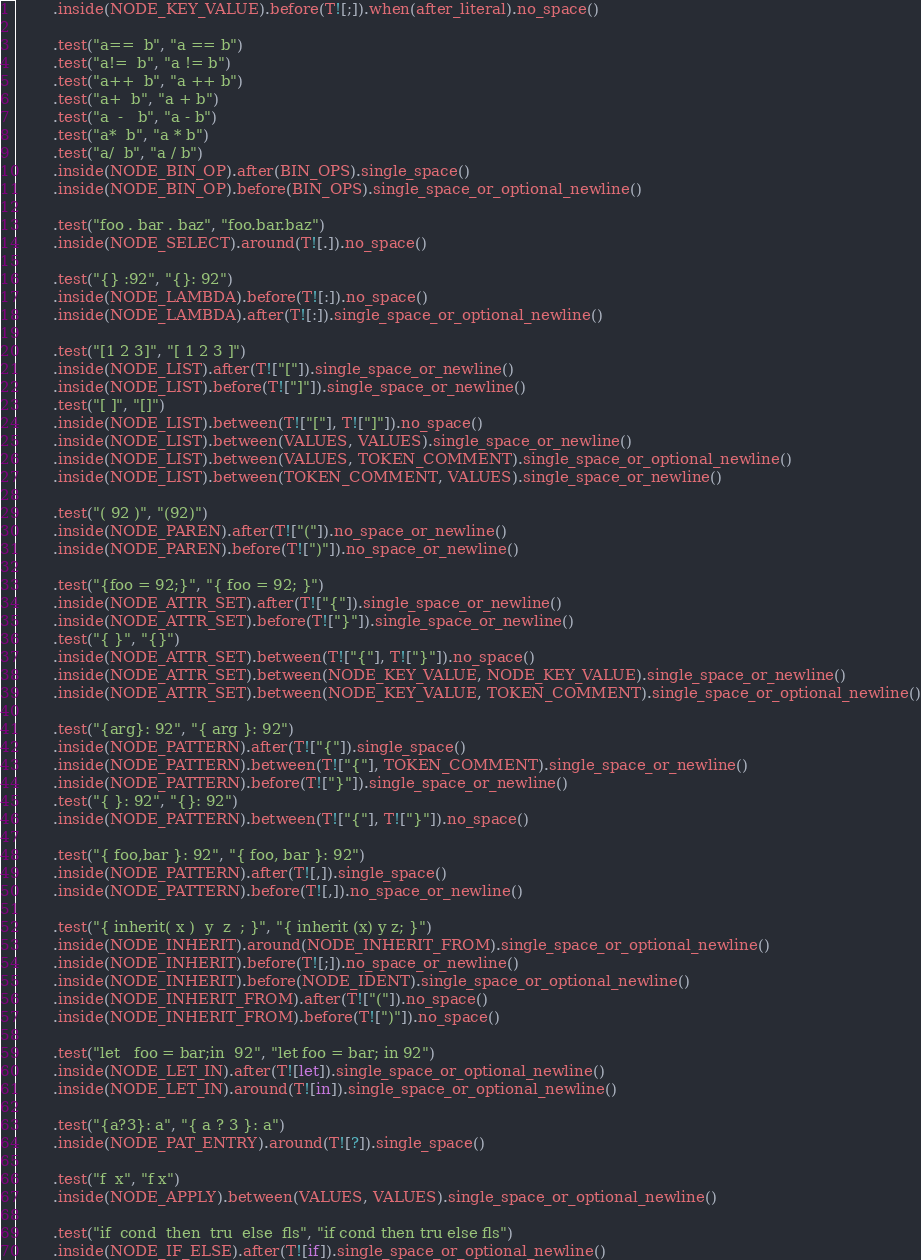Convert code to text. <code><loc_0><loc_0><loc_500><loc_500><_Rust_>        .inside(NODE_KEY_VALUE).before(T![;]).when(after_literal).no_space()

        .test("a==  b", "a == b")
        .test("a!=  b", "a != b")
        .test("a++  b", "a ++ b")
        .test("a+  b", "a + b")
        .test("a  -   b", "a - b")
        .test("a*  b", "a * b")
        .test("a/  b", "a / b")
        .inside(NODE_BIN_OP).after(BIN_OPS).single_space()
        .inside(NODE_BIN_OP).before(BIN_OPS).single_space_or_optional_newline()

        .test("foo . bar . baz", "foo.bar.baz")
        .inside(NODE_SELECT).around(T![.]).no_space()

        .test("{} :92", "{}: 92")
        .inside(NODE_LAMBDA).before(T![:]).no_space()
        .inside(NODE_LAMBDA).after(T![:]).single_space_or_optional_newline()

        .test("[1 2 3]", "[ 1 2 3 ]")
        .inside(NODE_LIST).after(T!["["]).single_space_or_newline()
        .inside(NODE_LIST).before(T!["]"]).single_space_or_newline()
        .test("[ ]", "[]")
        .inside(NODE_LIST).between(T!["["], T!["]"]).no_space()
        .inside(NODE_LIST).between(VALUES, VALUES).single_space_or_newline()
        .inside(NODE_LIST).between(VALUES, TOKEN_COMMENT).single_space_or_optional_newline()
        .inside(NODE_LIST).between(TOKEN_COMMENT, VALUES).single_space_or_newline()

        .test("( 92 )", "(92)")
        .inside(NODE_PAREN).after(T!["("]).no_space_or_newline()
        .inside(NODE_PAREN).before(T![")"]).no_space_or_newline()

        .test("{foo = 92;}", "{ foo = 92; }")
        .inside(NODE_ATTR_SET).after(T!["{"]).single_space_or_newline()
        .inside(NODE_ATTR_SET).before(T!["}"]).single_space_or_newline()
        .test("{ }", "{}")
        .inside(NODE_ATTR_SET).between(T!["{"], T!["}"]).no_space()
        .inside(NODE_ATTR_SET).between(NODE_KEY_VALUE, NODE_KEY_VALUE).single_space_or_newline()
        .inside(NODE_ATTR_SET).between(NODE_KEY_VALUE, TOKEN_COMMENT).single_space_or_optional_newline()

        .test("{arg}: 92", "{ arg }: 92")
        .inside(NODE_PATTERN).after(T!["{"]).single_space()
        .inside(NODE_PATTERN).between(T!["{"], TOKEN_COMMENT).single_space_or_newline()
        .inside(NODE_PATTERN).before(T!["}"]).single_space_or_newline()
        .test("{ }: 92", "{}: 92")
        .inside(NODE_PATTERN).between(T!["{"], T!["}"]).no_space()

        .test("{ foo,bar }: 92", "{ foo, bar }: 92")
        .inside(NODE_PATTERN).after(T![,]).single_space()
        .inside(NODE_PATTERN).before(T![,]).no_space_or_newline()

        .test("{ inherit( x )  y  z  ; }", "{ inherit (x) y z; }")
        .inside(NODE_INHERIT).around(NODE_INHERIT_FROM).single_space_or_optional_newline()
        .inside(NODE_INHERIT).before(T![;]).no_space_or_newline()
        .inside(NODE_INHERIT).before(NODE_IDENT).single_space_or_optional_newline()
        .inside(NODE_INHERIT_FROM).after(T!["("]).no_space()
        .inside(NODE_INHERIT_FROM).before(T![")"]).no_space()

        .test("let   foo = bar;in  92", "let foo = bar; in 92")
        .inside(NODE_LET_IN).after(T![let]).single_space_or_optional_newline()
        .inside(NODE_LET_IN).around(T![in]).single_space_or_optional_newline()
        
        .test("{a?3}: a", "{ a ? 3 }: a")
        .inside(NODE_PAT_ENTRY).around(T![?]).single_space()

        .test("f  x", "f x")
        .inside(NODE_APPLY).between(VALUES, VALUES).single_space_or_optional_newline()

        .test("if  cond  then  tru  else  fls", "if cond then tru else fls")
        .inside(NODE_IF_ELSE).after(T![if]).single_space_or_optional_newline()</code> 